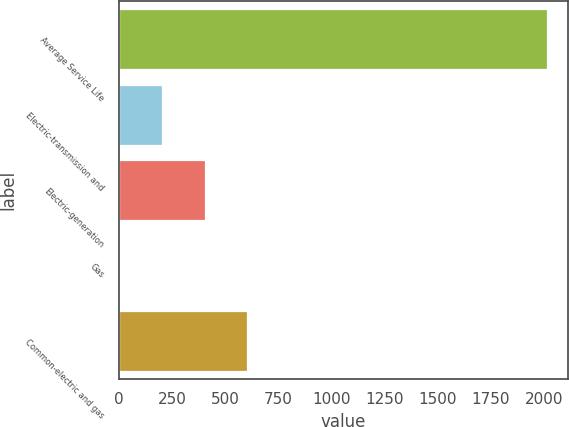Convert chart. <chart><loc_0><loc_0><loc_500><loc_500><bar_chart><fcel>Average Service Life<fcel>Electric-transmission and<fcel>Electric-generation<fcel>Gas<fcel>Common-electric and gas<nl><fcel>2012<fcel>203.03<fcel>404.03<fcel>2.03<fcel>605.03<nl></chart> 